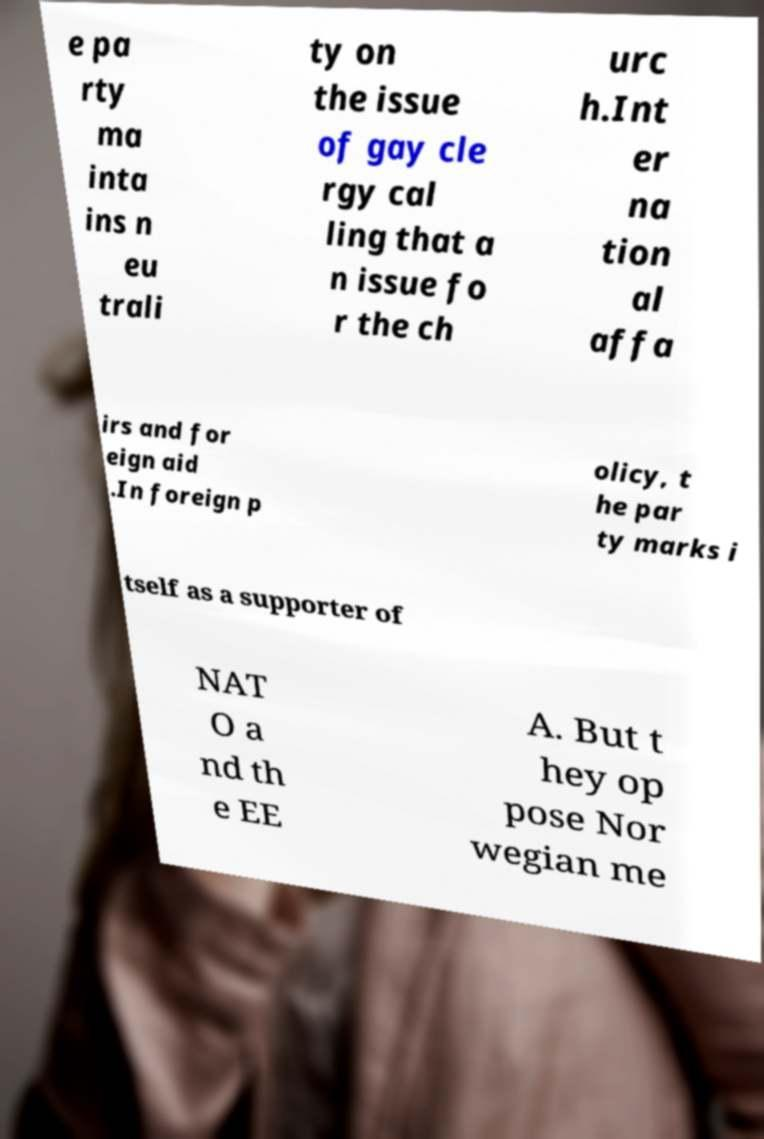Could you assist in decoding the text presented in this image and type it out clearly? e pa rty ma inta ins n eu trali ty on the issue of gay cle rgy cal ling that a n issue fo r the ch urc h.Int er na tion al affa irs and for eign aid .In foreign p olicy, t he par ty marks i tself as a supporter of NAT O a nd th e EE A. But t hey op pose Nor wegian me 